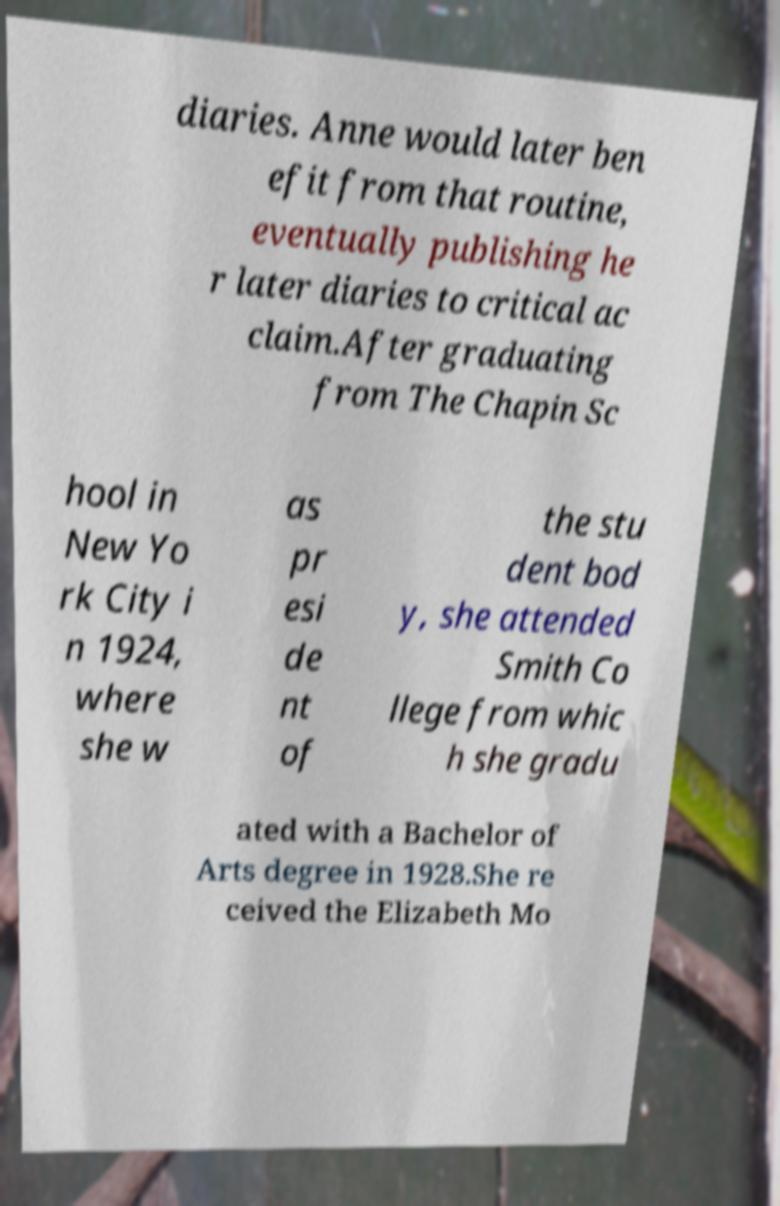Could you assist in decoding the text presented in this image and type it out clearly? diaries. Anne would later ben efit from that routine, eventually publishing he r later diaries to critical ac claim.After graduating from The Chapin Sc hool in New Yo rk City i n 1924, where she w as pr esi de nt of the stu dent bod y, she attended Smith Co llege from whic h she gradu ated with a Bachelor of Arts degree in 1928.She re ceived the Elizabeth Mo 